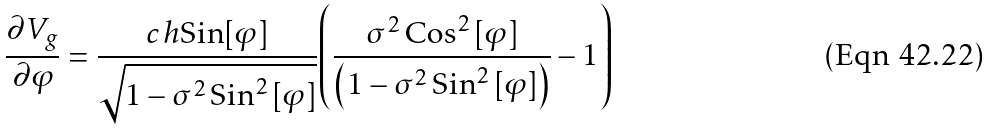<formula> <loc_0><loc_0><loc_500><loc_500>\frac { { \partial } V _ { g } } { \partial { \varphi } } = \frac { c \, h \text {Sin} [ \varphi ] } { { \sqrt { 1 - \sigma ^ { 2 } \, \text {Sin} ^ { 2 } \, [ \varphi ] } } } { \left ( \frac { \sigma ^ { 2 } \, \text {Cos} ^ { 2 } \, [ \varphi ] } { \left ( 1 - \sigma ^ { 2 } \, \text {Sin} ^ { 2 } \, [ \varphi ] \right ) } - 1 \right ) }</formula> 